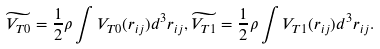Convert formula to latex. <formula><loc_0><loc_0><loc_500><loc_500>\widetilde { V _ { T 0 } } = \frac { 1 } { 2 } \rho \int V _ { T 0 } ( r _ { i j } ) d ^ { 3 } r _ { i j } , \widetilde { V _ { T 1 } } = \frac { 1 } { 2 } \rho \int V _ { T 1 } ( r _ { i j } ) d ^ { 3 } r _ { i j } .</formula> 